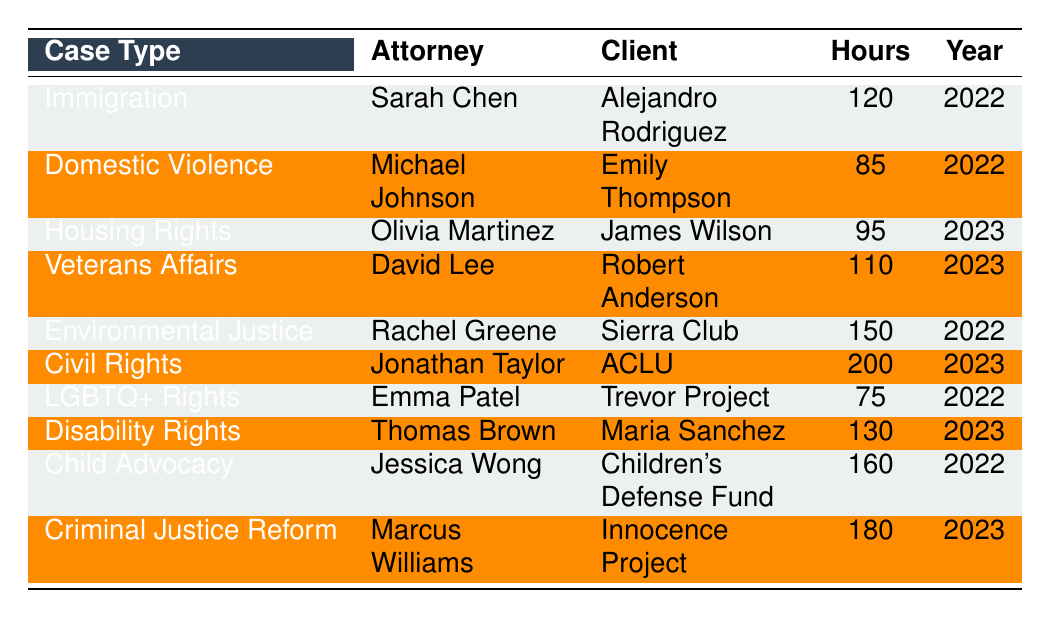What is the highest number of hours spent on a pro bono case? The highest number of hours recorded in the table is 200, associated with the Civil Rights case.
Answer: 200 Who handled the Domestic Violence case in 2022? According to the table, the Domestic Violence case was handled by Michael Johnson.
Answer: Michael Johnson How many hours did Rachel Greene spend on Environmental Justice cases? The table shows that Rachel Greene spent 150 hours on Environmental Justice in 2022.
Answer: 150 Which attorney worked on the Child Advocacy case? The table indicates that Jessica Wong was the attorney for the Child Advocacy case.
Answer: Jessica Wong What is the average number of hours spent across all cases listed in 2022? The cases in 2022 are Immigration, Domestic Violence, Environmental Justice, LGBTQ+ Rights, and Child Advocacy with hours 120, 85, 150, 75, and 160 respectively. Summing these gives 590 hours, and dividing by 5 cases gives an average of 118 hours.
Answer: 118 Is there a case type that involved more than 150 hours? Yes, the Civil Rights case required 200 hours, which is more than 150 hours.
Answer: Yes What was the total number of hours spent on pro bono cases by attorneys in 2023? The hours for 2023 include 95 (Housing Rights), 110 (Veterans Affairs), 200 (Civil Rights), 130 (Disability Rights), and 180 (Criminal Justice Reform). Adding these gives 715 hours for 2023.
Answer: 715 Which attorney had the least number of hours in their pro bono cases? The least hours are associated with Emma Patel, who spent 75 hours on the LGBTQ+ Rights case in 2022.
Answer: Emma Patel How many attorneys worked on cases related to Civil Rights? The table shows only one case type, Civil Rights, which was handled by Jonathan Taylor, indicating one attorney worked on this case.
Answer: 1 What is the difference in hours spent between the case with the most hours and the case with the least hours? The case with the most hours is Civil Rights at 200 hours and the least is LGBTQ+ Rights at 75 hours. The difference is 200 - 75 = 125 hours.
Answer: 125 